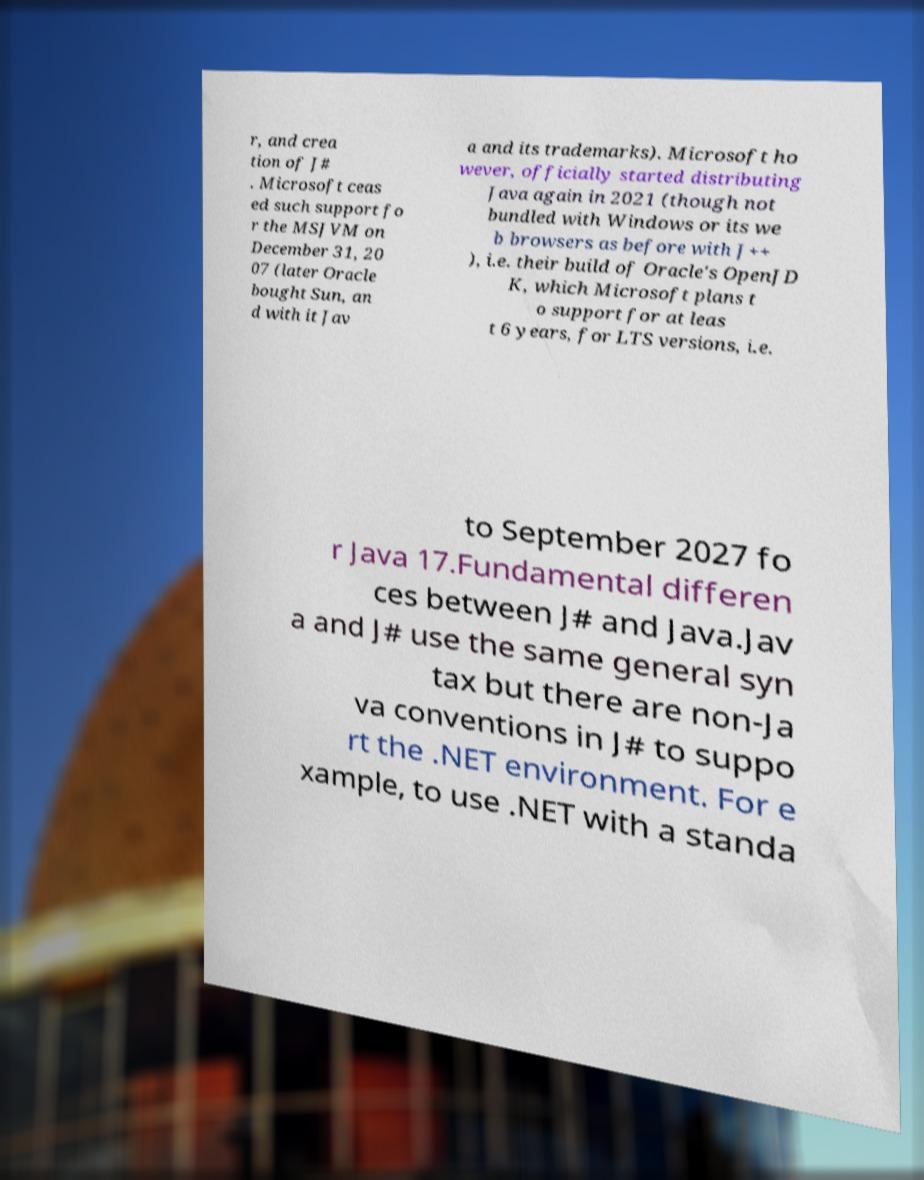Can you read and provide the text displayed in the image?This photo seems to have some interesting text. Can you extract and type it out for me? r, and crea tion of J# . Microsoft ceas ed such support fo r the MSJVM on December 31, 20 07 (later Oracle bought Sun, an d with it Jav a and its trademarks). Microsoft ho wever, officially started distributing Java again in 2021 (though not bundled with Windows or its we b browsers as before with J++ ), i.e. their build of Oracle's OpenJD K, which Microsoft plans t o support for at leas t 6 years, for LTS versions, i.e. to September 2027 fo r Java 17.Fundamental differen ces between J# and Java.Jav a and J# use the same general syn tax but there are non-Ja va conventions in J# to suppo rt the .NET environment. For e xample, to use .NET with a standa 